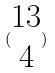<formula> <loc_0><loc_0><loc_500><loc_500>( \begin{matrix} 1 3 \\ 4 \end{matrix} )</formula> 